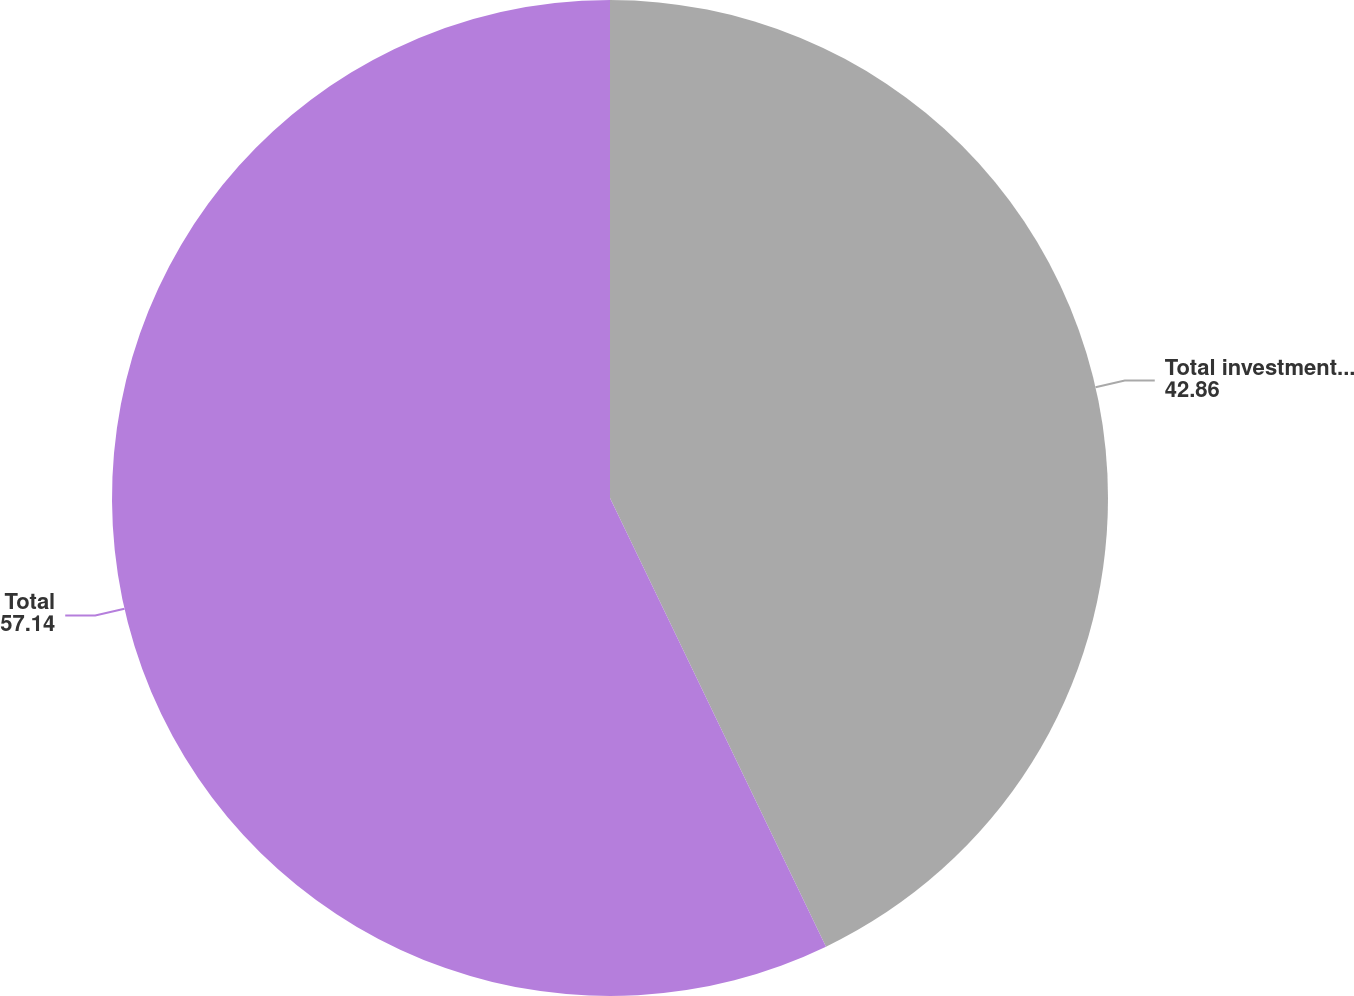<chart> <loc_0><loc_0><loc_500><loc_500><pie_chart><fcel>Total investments at fair<fcel>Total<nl><fcel>42.86%<fcel>57.14%<nl></chart> 